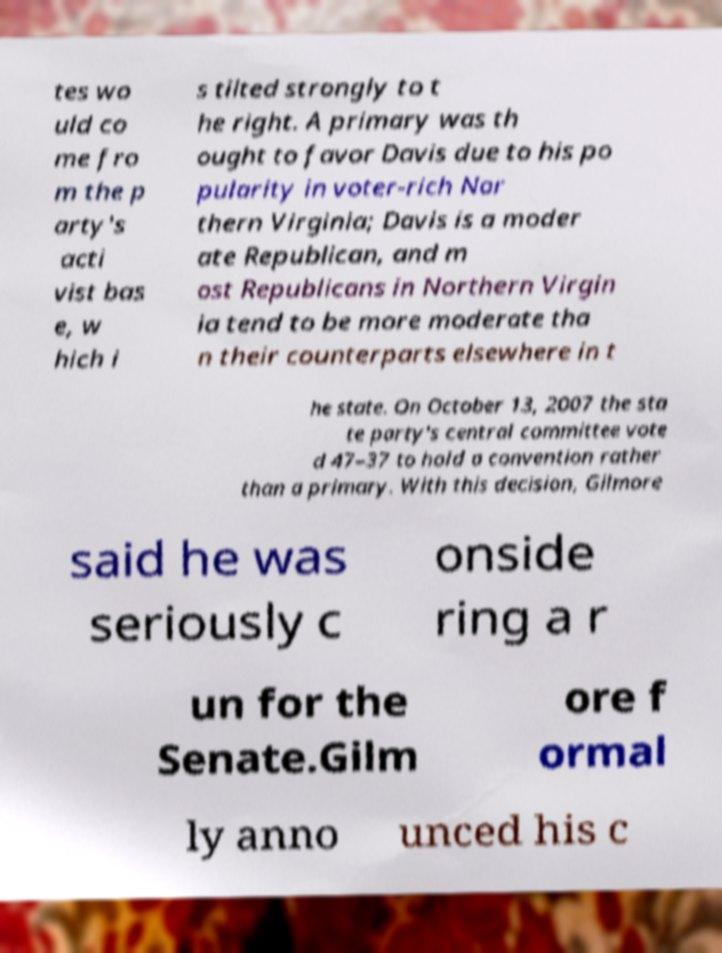There's text embedded in this image that I need extracted. Can you transcribe it verbatim? tes wo uld co me fro m the p arty's acti vist bas e, w hich i s tilted strongly to t he right. A primary was th ought to favor Davis due to his po pularity in voter-rich Nor thern Virginia; Davis is a moder ate Republican, and m ost Republicans in Northern Virgin ia tend to be more moderate tha n their counterparts elsewhere in t he state. On October 13, 2007 the sta te party's central committee vote d 47–37 to hold a convention rather than a primary. With this decision, Gilmore said he was seriously c onside ring a r un for the Senate.Gilm ore f ormal ly anno unced his c 